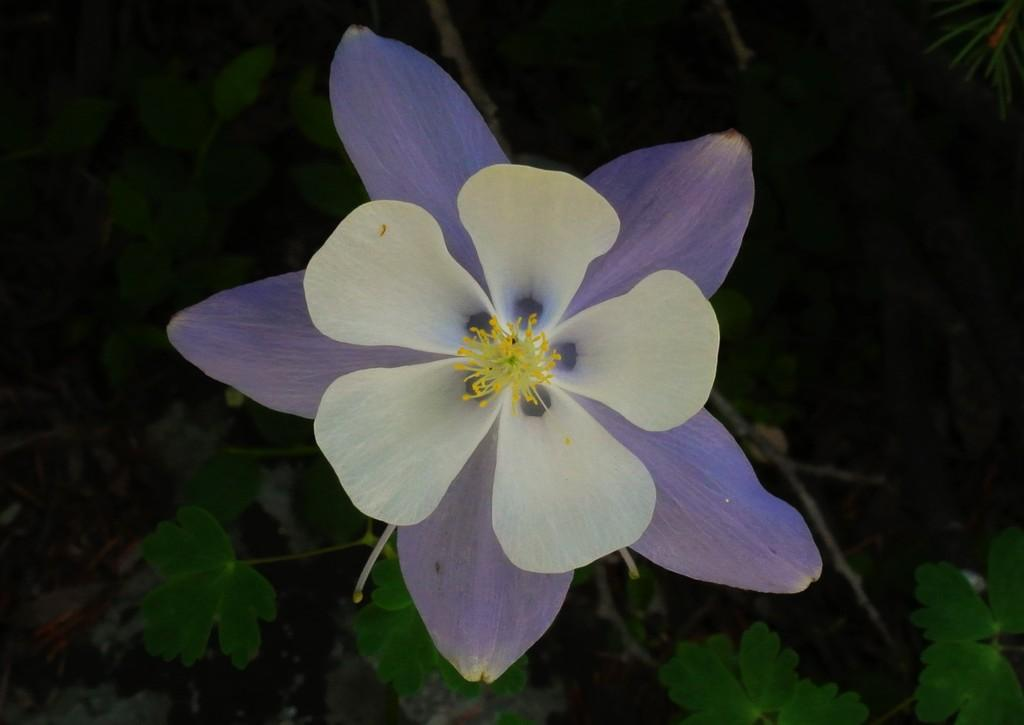What type of plant can be seen in the image? There is a flower in the image. What colors are present on the flower? The flower has lavender and white colors. What other parts of the plant are visible in the image? There are leaves and stems in the background of the image. What time is the flower expected to bloom in the image? The image does not provide information about the time the flower is expected to bloom. 